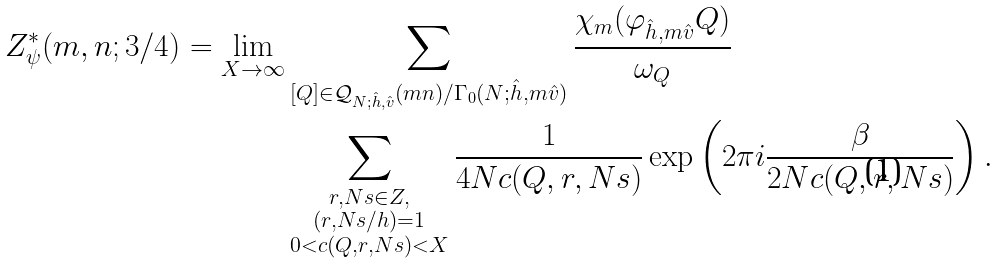<formula> <loc_0><loc_0><loc_500><loc_500>Z ^ { * } _ { \psi } ( m , n ; 3 / 4 ) = \lim _ { X \to \infty } & \sum _ { [ Q ] \in \mathcal { Q } _ { N ; \hat { h } , \hat { v } } ( m n ) / \Gamma _ { 0 } ( N ; \hat { h } , m \hat { v } ) } \frac { \chi _ { m } ( \varphi _ { \hat { h } , m \hat { v } } Q ) } { \omega _ { Q } } \\ & \sum _ { \substack { r , N s \in Z , \\ ( r , N s / h ) = 1 \\ 0 < c ( Q , r , N s ) < X } } \frac { 1 } { 4 N c ( Q , r , N s ) } \exp \left ( 2 \pi i \frac { \beta } { 2 N c ( Q , r , N s ) } \right ) .</formula> 